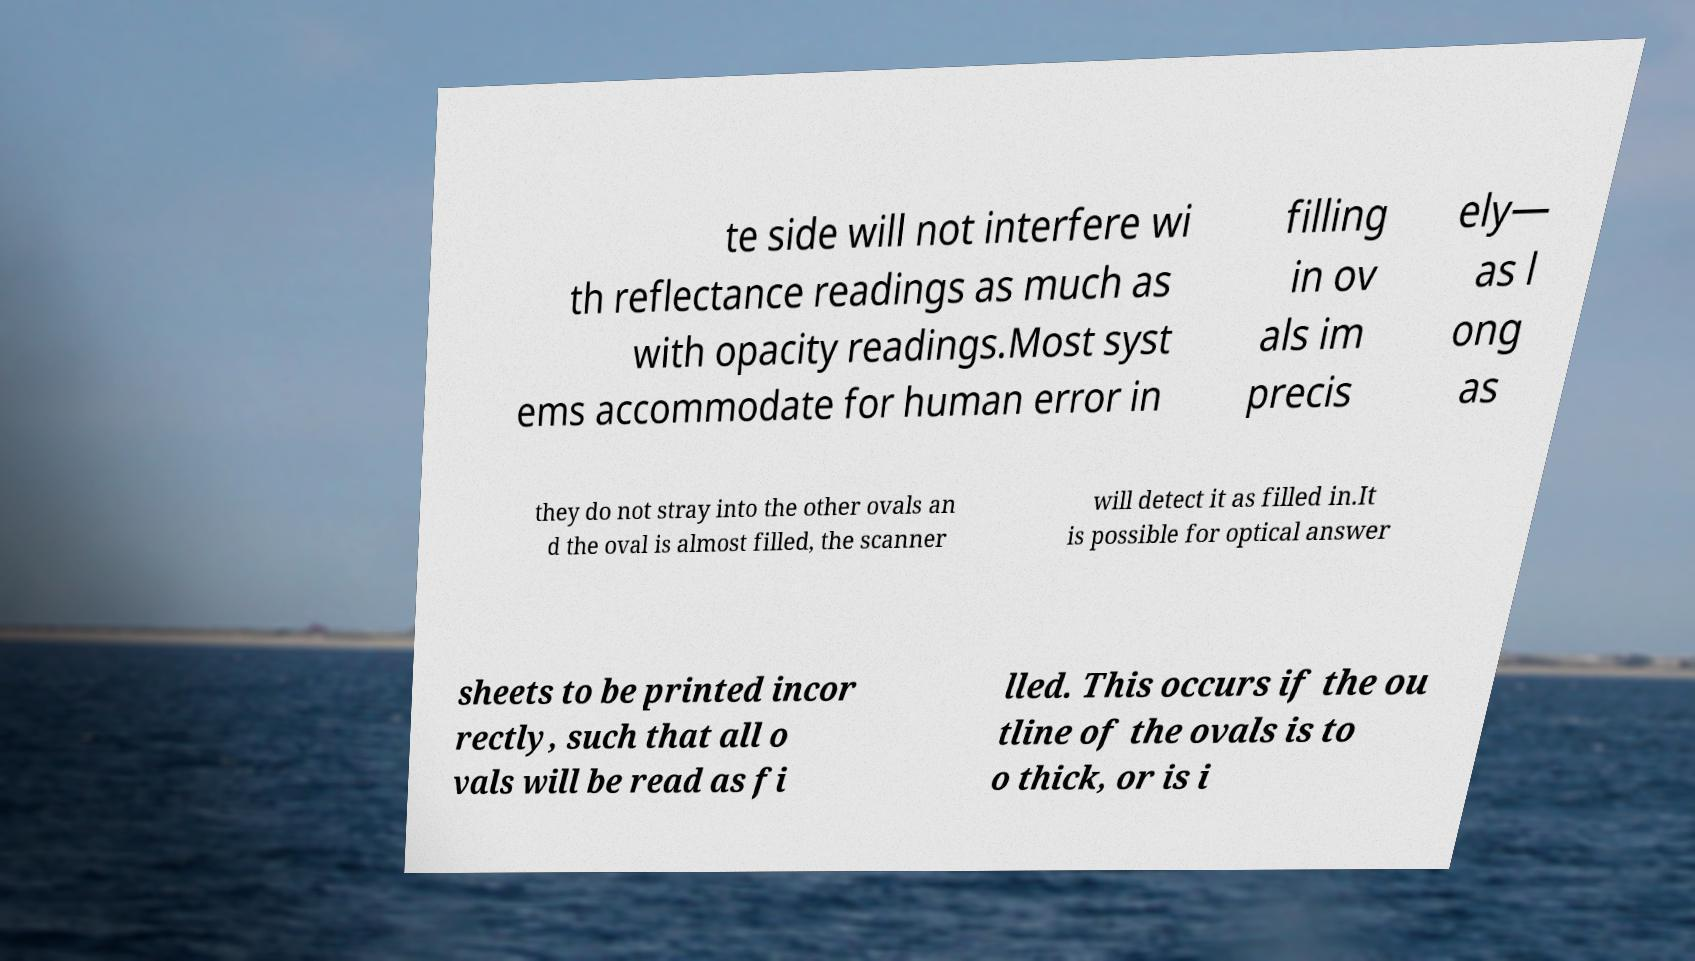Can you read and provide the text displayed in the image?This photo seems to have some interesting text. Can you extract and type it out for me? te side will not interfere wi th reflectance readings as much as with opacity readings.Most syst ems accommodate for human error in filling in ov als im precis ely— as l ong as they do not stray into the other ovals an d the oval is almost filled, the scanner will detect it as filled in.It is possible for optical answer sheets to be printed incor rectly, such that all o vals will be read as fi lled. This occurs if the ou tline of the ovals is to o thick, or is i 